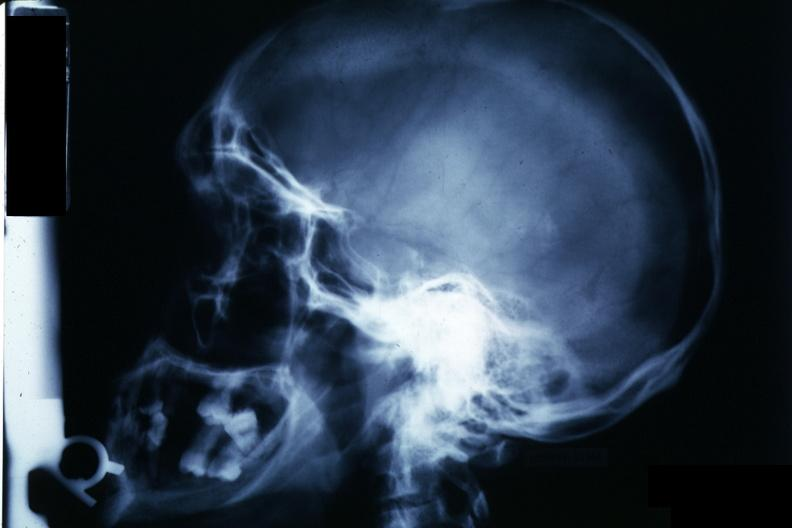what is present?
Answer the question using a single word or phrase. Chromophobe adenoma 